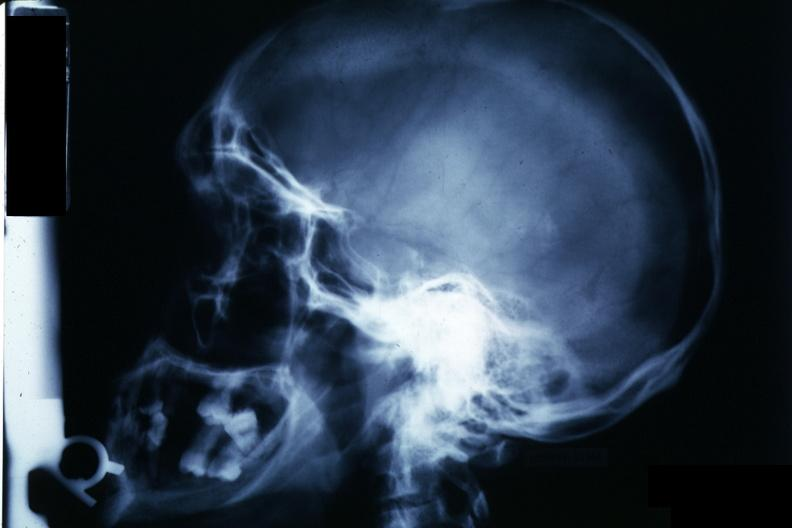what is present?
Answer the question using a single word or phrase. Chromophobe adenoma 